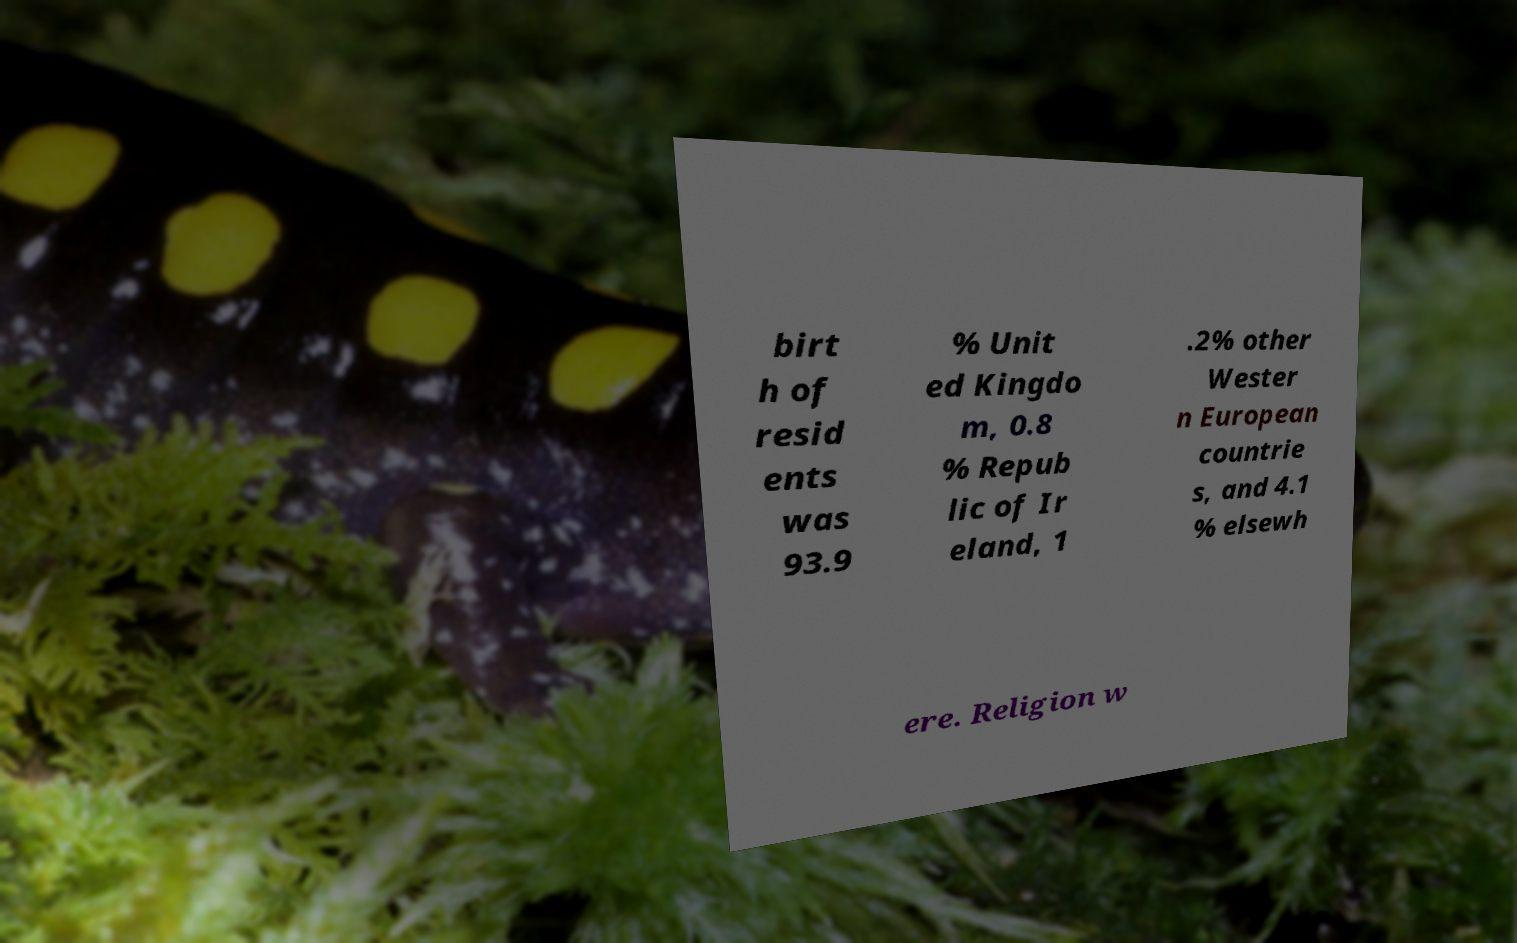Can you accurately transcribe the text from the provided image for me? birt h of resid ents was 93.9 % Unit ed Kingdo m, 0.8 % Repub lic of Ir eland, 1 .2% other Wester n European countrie s, and 4.1 % elsewh ere. Religion w 